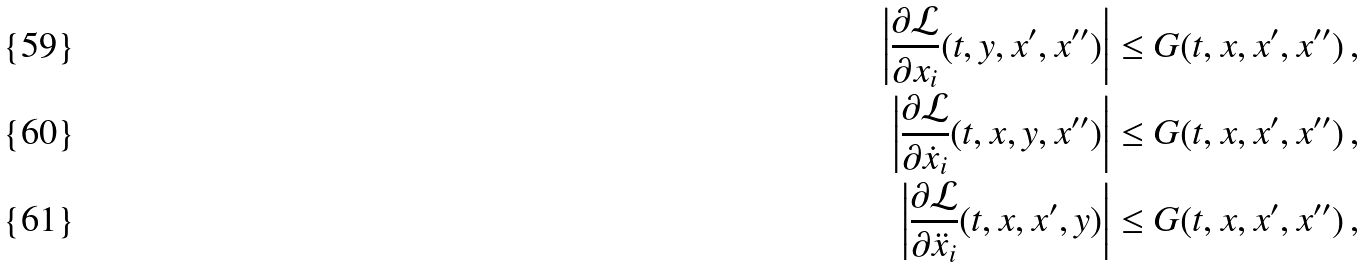Convert formula to latex. <formula><loc_0><loc_0><loc_500><loc_500>\left | \frac { \partial \mathcal { L } } { \partial x _ { i } } ( t , y , x ^ { \prime } , x ^ { \prime \prime } ) \right | & \leq G ( t , x , x ^ { \prime } , x ^ { \prime \prime } ) \, , \\ \left | \frac { \partial \mathcal { L } } { \partial \dot { x } _ { i } } ( t , x , y , x ^ { \prime \prime } ) \right | & \leq G ( t , x , x ^ { \prime } , x ^ { \prime \prime } ) \, , \\ \left | \frac { \partial \mathcal { L } } { \partial \ddot { x } _ { i } } ( t , x , x ^ { \prime } , y ) \right | & \leq G ( t , x , x ^ { \prime } , x ^ { \prime \prime } ) \, ,</formula> 